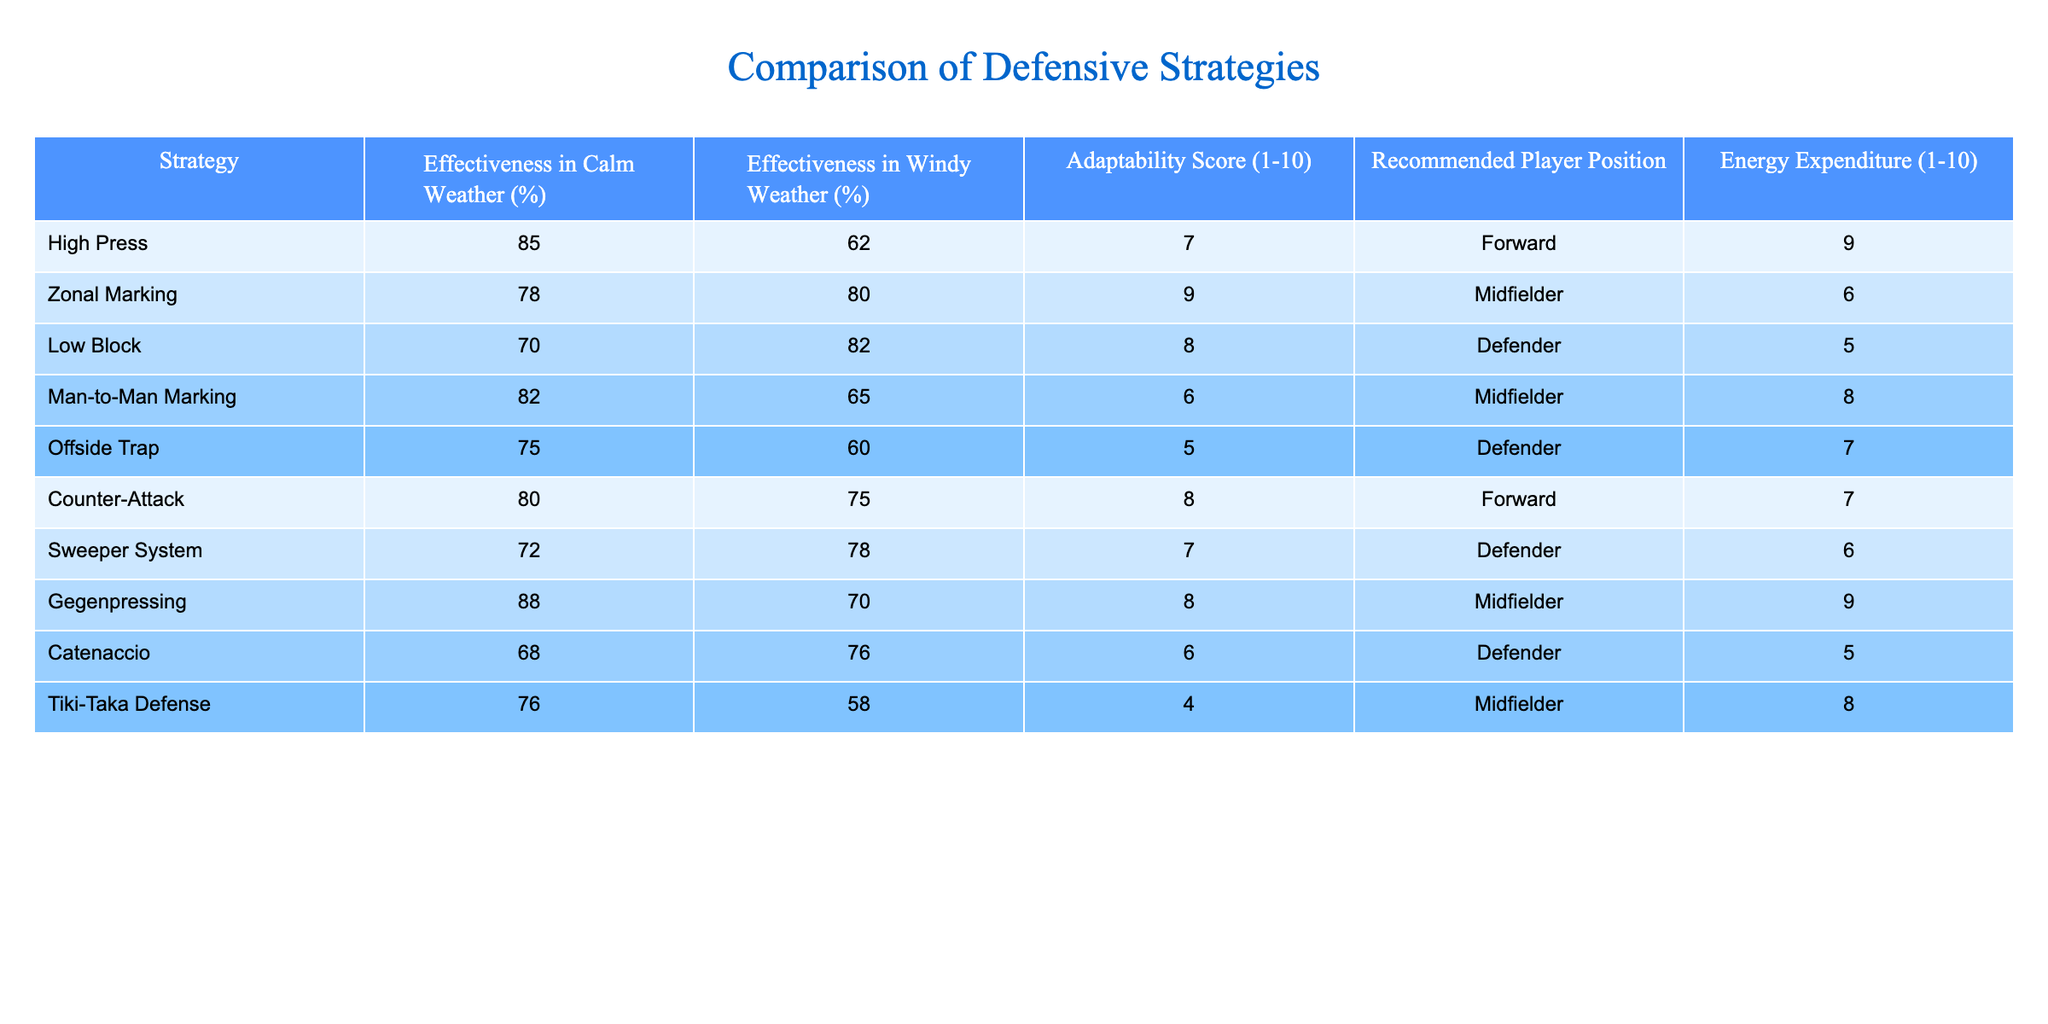What is the effectiveness of High Press in calm weather? According to the table, the effectiveness of High Press in calm weather is given directly as 85%.
Answer: 85% Which strategy has the highest adaptability score? The adaptability scores are listed in the table; by examining them, Zonal Marking has the highest score of 9.
Answer: Zonal Marking Is the effectiveness of Zonal Marking higher in windy or calm weather? The effectiveness of Zonal Marking is 78% in calm weather and 80% in windy weather. Since 80% is greater than 78%, it is higher in windy weather.
Answer: Yes What is the average effectiveness of defensive strategies in windy weather? To find the average effectiveness in windy weather, we add the percentages (62 + 80 + 82 + 65 + 60 + 75 + 78 + 70 + 76 + 58 =  736) and divide by the number of strategies (10). Thus, the average is 736/10 = 73.6%.
Answer: 73.6% Which three strategies have an effectiveness above 80% in calm weather? Checking the calm weather effectiveness, we find that High Press (85%), Man-to-Man Marking (82%), and Gegenpressing (88%) all exceed 80%.
Answer: High Press, Man-to-Man Marking, Gegenpressing Does the Counter-Attack strategy have a higher effectiveness in calm or windy weather? The effectiveness of Counter-Attack is 80% in calm weather and 75% in windy weather. Since 80% is higher than 75%, it is more effective in calm weather.
Answer: Calm weather Which two strategies are most energy-consuming and what are their effectiveness in windy weather? The two strategies with the highest energy expenditure scores are High Press (9) and Man-to-Man Marking (8). Their effectiveness in windy weather is 62% and 65%, respectively.
Answer: High Press 62%, Man-to-Man Marking 65% What is the difference in effectiveness between Catenaccio in calm and windy weather? Catenaccio has an effectiveness of 68% in calm weather and 76% in windy weather. The difference is 76% - 68% = 8%.
Answer: 8% Which player position has the lowest average effectiveness in windy weather? By examining the data, Low Block has the lowest effectiveness in windy weather at 82%, while Offside Trap has 60%. Hence, Offside Trap has the lowest effectiveness.
Answer: Defender (Offside Trap) What is the relationship between energy expenditure and effectiveness in windy weather? Analyzing the table, we observe that generally, strategies with lower energy expenditure tend to have higher effectiveness in windy weather (e.g., Low Block has 82% effectiveness and 5 energy expenditure). Therefore, it suggests that strategies requiring less energy might perform better in windy conditions.
Answer: Generally inverse relationship 